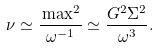<formula> <loc_0><loc_0><loc_500><loc_500>\nu \simeq \frac { \L \max ^ { 2 } } { \omega ^ { - 1 } } \simeq \frac { G ^ { 2 } \Sigma ^ { 2 } } { \omega ^ { 3 } } .</formula> 